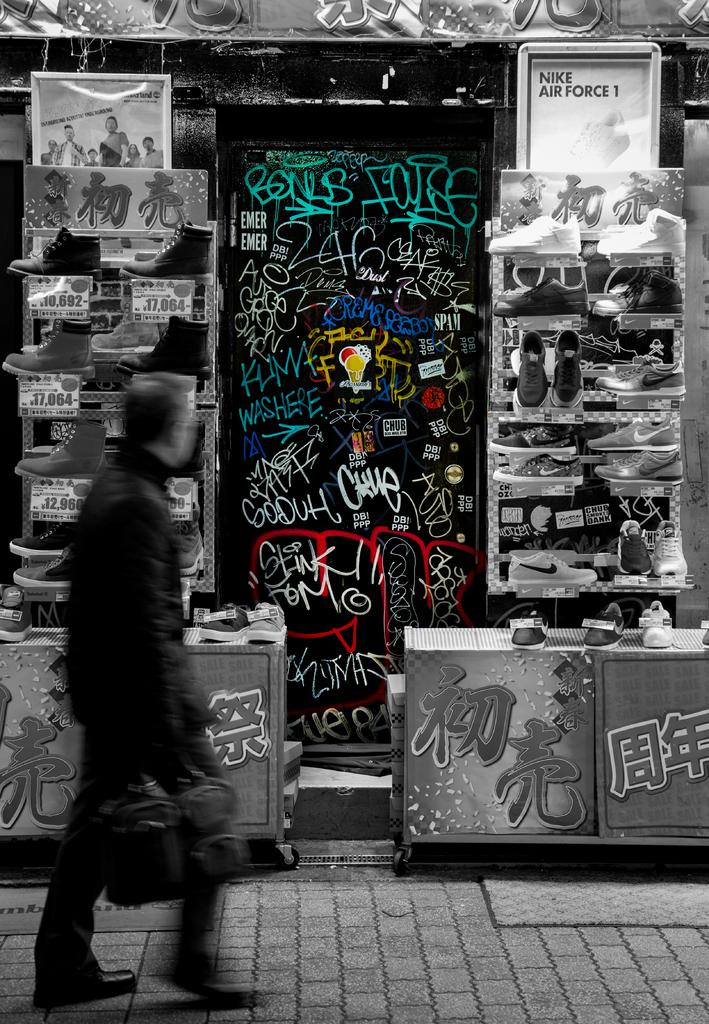What is the man in the image doing? The man is standing on the pavement. What is the man holding in his hand? The man is holding a bag in his hand. What can be seen in the background of the image? There are banners, tables, and shoes with tags in the background of the image. What type of tree can be seen in the image? There is no tree present in the image. How does the sand affect the man's movement in the image? There is no sand present in the image, so it does not affect the man's movement. 